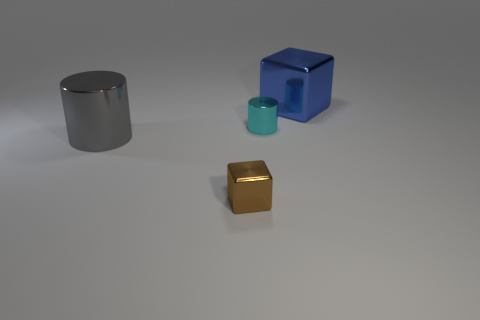Can you describe the texture of the various objects shown? Certainly! The large cylindrical object and the small cube both have smooth and highly reflective surfaces, indicative of polished metal. The blue cube appears to have a matte finish, likely plastic, and its edges and corners are more sharply defined than the metallic objects. 